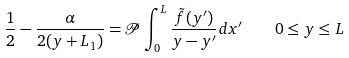<formula> <loc_0><loc_0><loc_500><loc_500>\frac { 1 } { 2 } - \frac { \alpha } { 2 ( y + L _ { 1 } ) } = \mathcal { P } \int _ { 0 } ^ { L } \frac { \tilde { f } ( y ^ { \prime } ) } { y - y ^ { \prime } } d x ^ { \prime } \quad 0 \leq y \leq L</formula> 